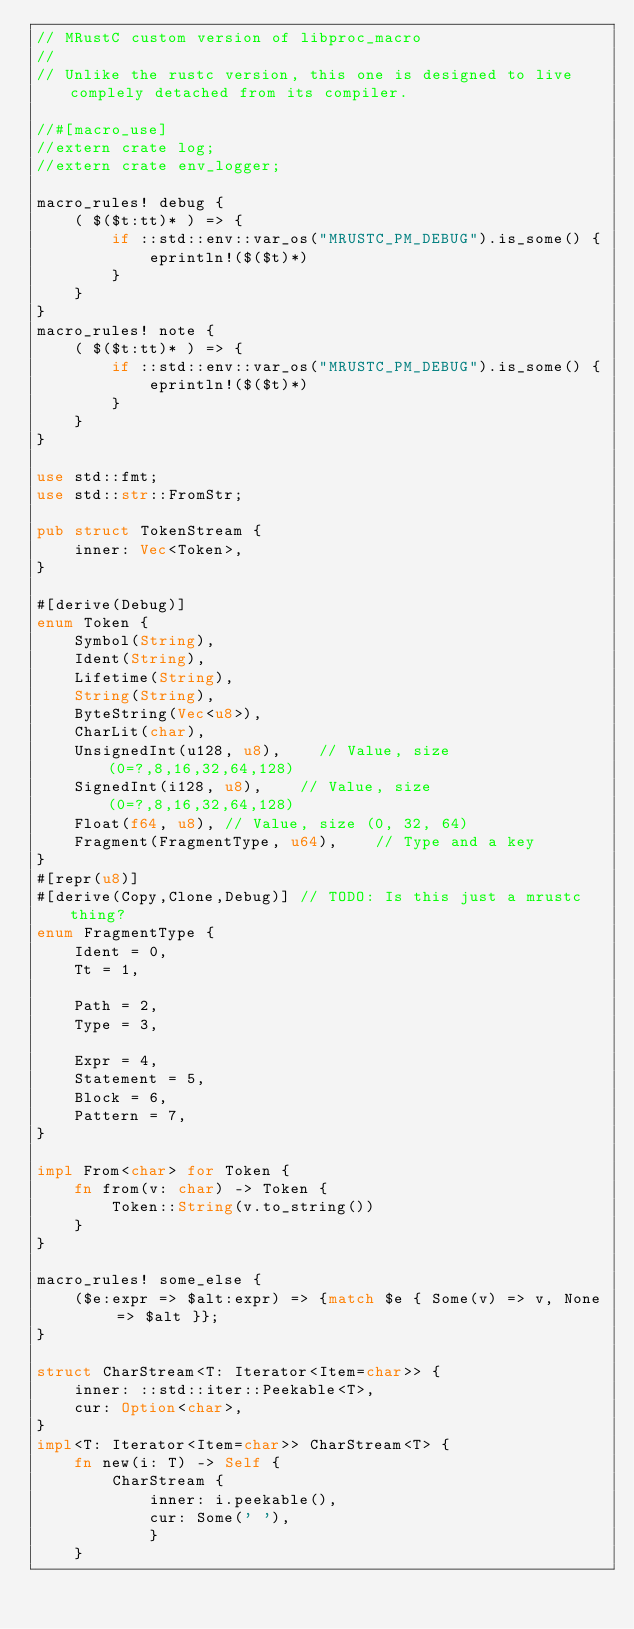<code> <loc_0><loc_0><loc_500><loc_500><_Rust_>// MRustC custom version of libproc_macro
//
// Unlike the rustc version, this one is designed to live complely detached from its compiler.

//#[macro_use]
//extern crate log;
//extern crate env_logger;

macro_rules! debug {
    ( $($t:tt)* ) => {
        if ::std::env::var_os("MRUSTC_PM_DEBUG").is_some() {
            eprintln!($($t)*)
        }
    }
}
macro_rules! note {
    ( $($t:tt)* ) => {
        if ::std::env::var_os("MRUSTC_PM_DEBUG").is_some() {
            eprintln!($($t)*)
        }
    }
}

use std::fmt;
use std::str::FromStr;

pub struct TokenStream {
    inner: Vec<Token>,
}

#[derive(Debug)]
enum Token {
    Symbol(String),
    Ident(String),
    Lifetime(String),
    String(String),
    ByteString(Vec<u8>),
    CharLit(char),
    UnsignedInt(u128, u8),    // Value, size (0=?,8,16,32,64,128)
    SignedInt(i128, u8),    // Value, size (0=?,8,16,32,64,128)
    Float(f64, u8), // Value, size (0, 32, 64)
    Fragment(FragmentType, u64),    // Type and a key
}
#[repr(u8)]
#[derive(Copy,Clone,Debug)] // TODO: Is this just a mrustc thing?
enum FragmentType {
    Ident = 0,
    Tt = 1,

    Path = 2,
    Type = 3,

    Expr = 4,
    Statement = 5,
    Block = 6,
    Pattern = 7,
}

impl From<char> for Token {
    fn from(v: char) -> Token {
        Token::String(v.to_string())
    }
}

macro_rules! some_else {
    ($e:expr => $alt:expr) => {match $e { Some(v) => v, None => $alt }};
}

struct CharStream<T: Iterator<Item=char>> {
    inner: ::std::iter::Peekable<T>,
    cur: Option<char>,
}
impl<T: Iterator<Item=char>> CharStream<T> {
    fn new(i: T) -> Self {
        CharStream {
            inner: i.peekable(),
            cur: Some(' '),
            }
    }</code> 